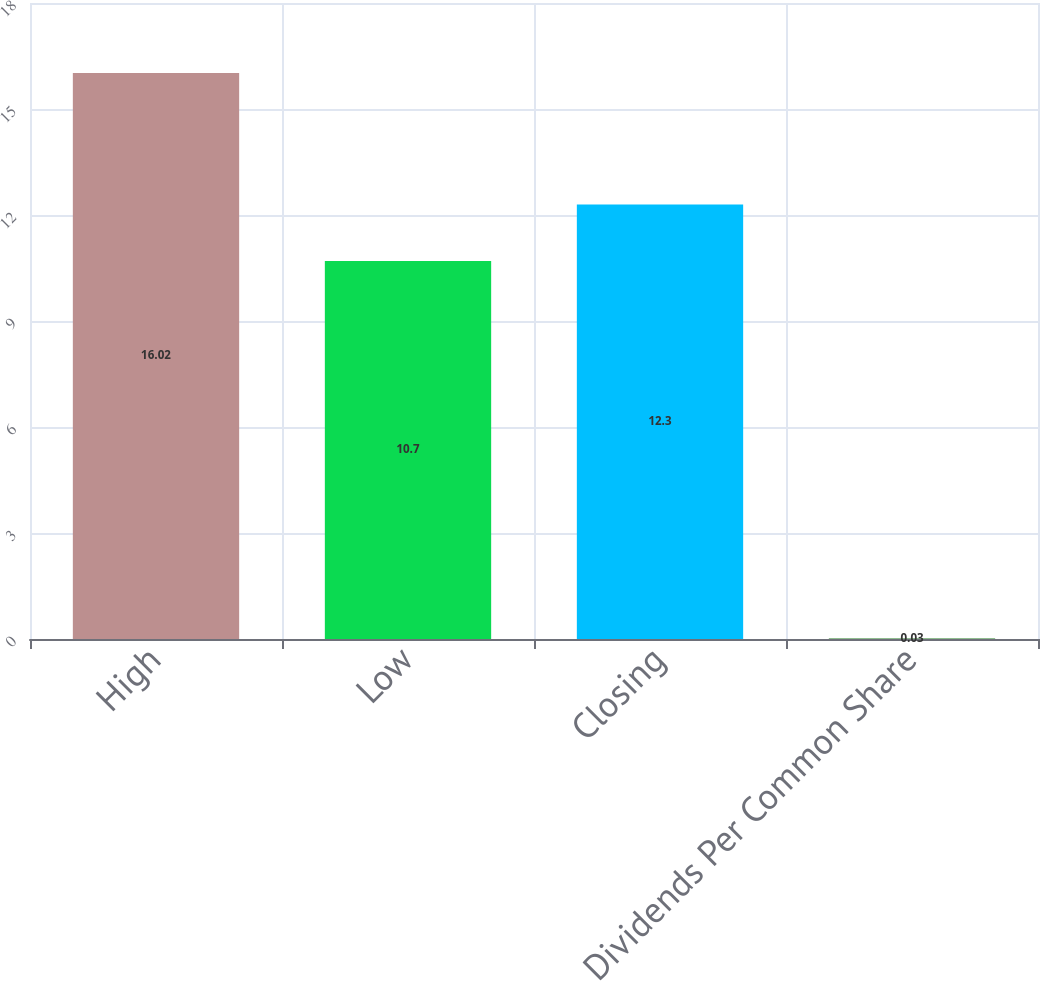Convert chart to OTSL. <chart><loc_0><loc_0><loc_500><loc_500><bar_chart><fcel>High<fcel>Low<fcel>Closing<fcel>Dividends Per Common Share<nl><fcel>16.02<fcel>10.7<fcel>12.3<fcel>0.03<nl></chart> 